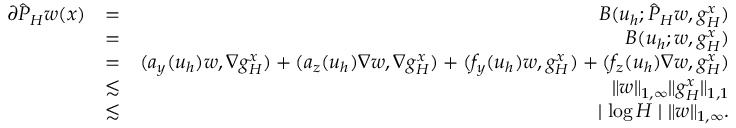<formula> <loc_0><loc_0><loc_500><loc_500>\begin{array} { r l r } { \partial \hat { P } _ { H } w ( { x } ) } & { = } & { B ( u _ { h } ; \hat { P } _ { H } w , g _ { H } ^ { x } ) } \\ & { = } & { B ( u _ { h } ; w , g _ { H } ^ { x } ) } \\ & { = } & { ( a _ { y } ( u _ { h } ) w , \nabla g _ { H } ^ { x } ) + ( a _ { z } ( u _ { h } ) \nabla w , \nabla g _ { H } ^ { x } ) + ( f _ { y } ( u _ { h } ) w , g _ { H } ^ { x } ) + ( f _ { z } ( u _ { h } ) \nabla w , g _ { H } ^ { x } ) } \\ & { \lesssim } & { \| w \| _ { 1 , \infty } \| g _ { H } ^ { x } \| _ { 1 , 1 } } \\ & { \lesssim } & { | \log H | \| w \| _ { 1 , \infty } . } \end{array}</formula> 